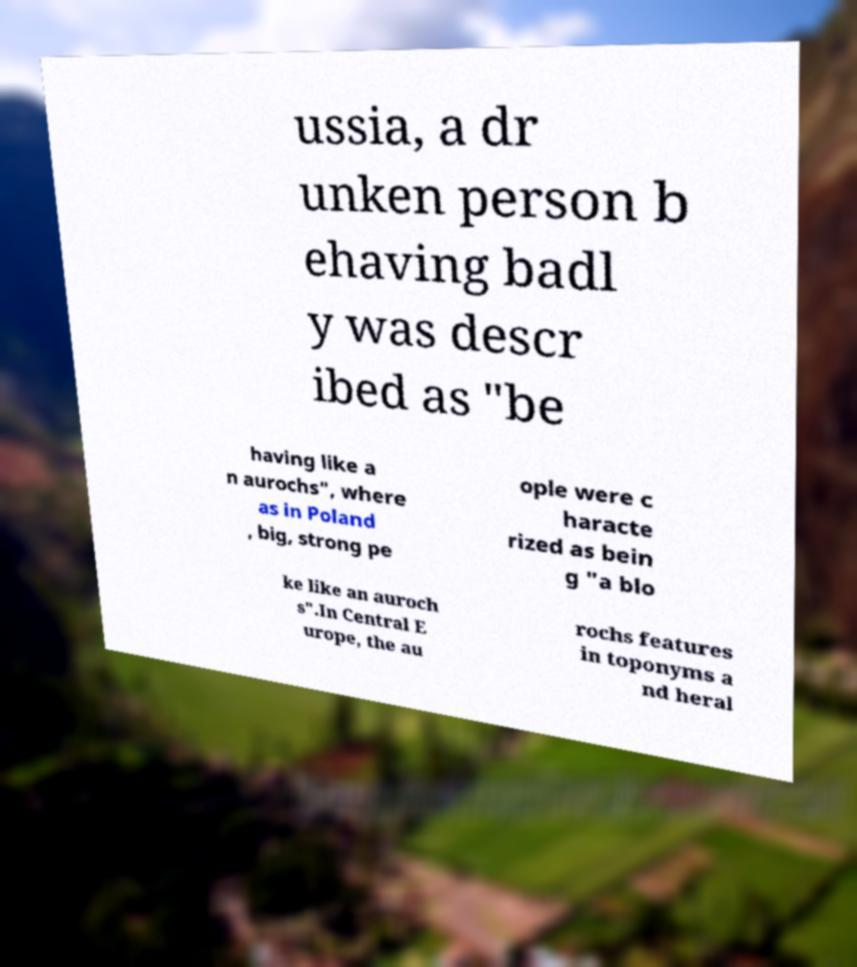Could you assist in decoding the text presented in this image and type it out clearly? ussia, a dr unken person b ehaving badl y was descr ibed as "be having like a n aurochs", where as in Poland , big, strong pe ople were c haracte rized as bein g "a blo ke like an auroch s".In Central E urope, the au rochs features in toponyms a nd heral 